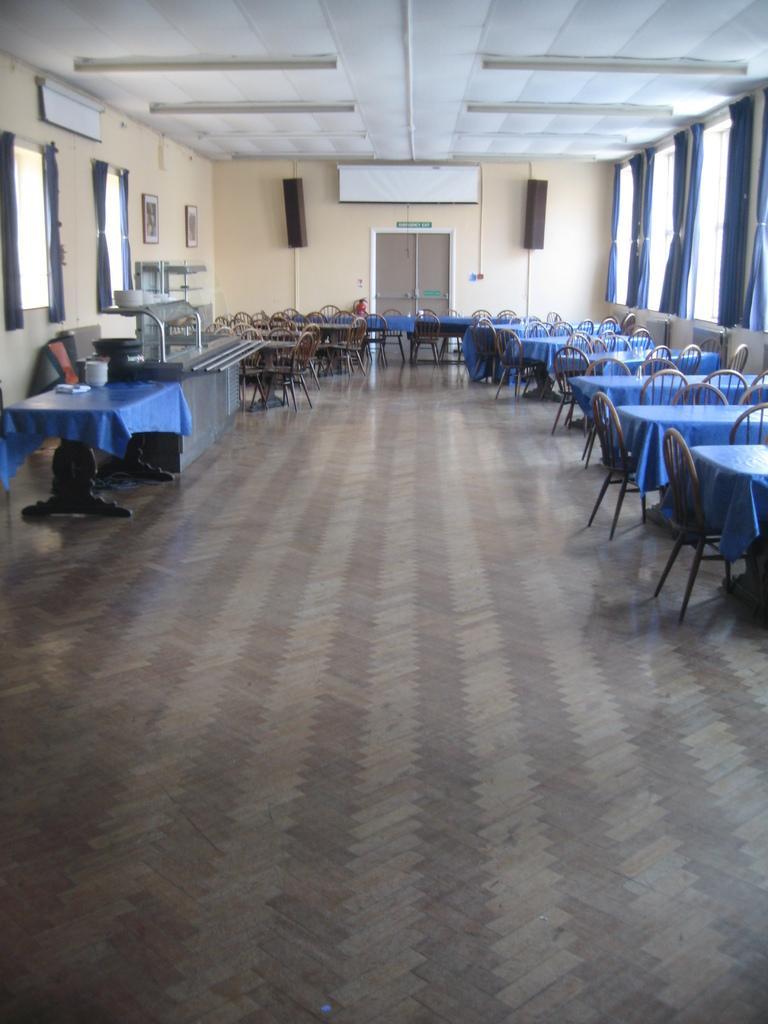Can you describe this image briefly? In this room we can see chairs at the tables on the floor and we can see tables and some items on it and there are some objects on the floor. We can also see wall,windows,curtains,two speakers on the wall and lights on the roof top. 